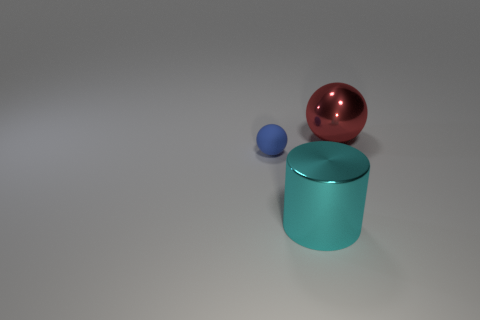Add 1 large things. How many objects exist? 4 Subtract all balls. How many objects are left? 1 Add 2 big cyan metallic objects. How many big cyan metallic objects are left? 3 Add 3 tiny red shiny spheres. How many tiny red shiny spheres exist? 3 Subtract 0 cyan blocks. How many objects are left? 3 Subtract all balls. Subtract all matte things. How many objects are left? 0 